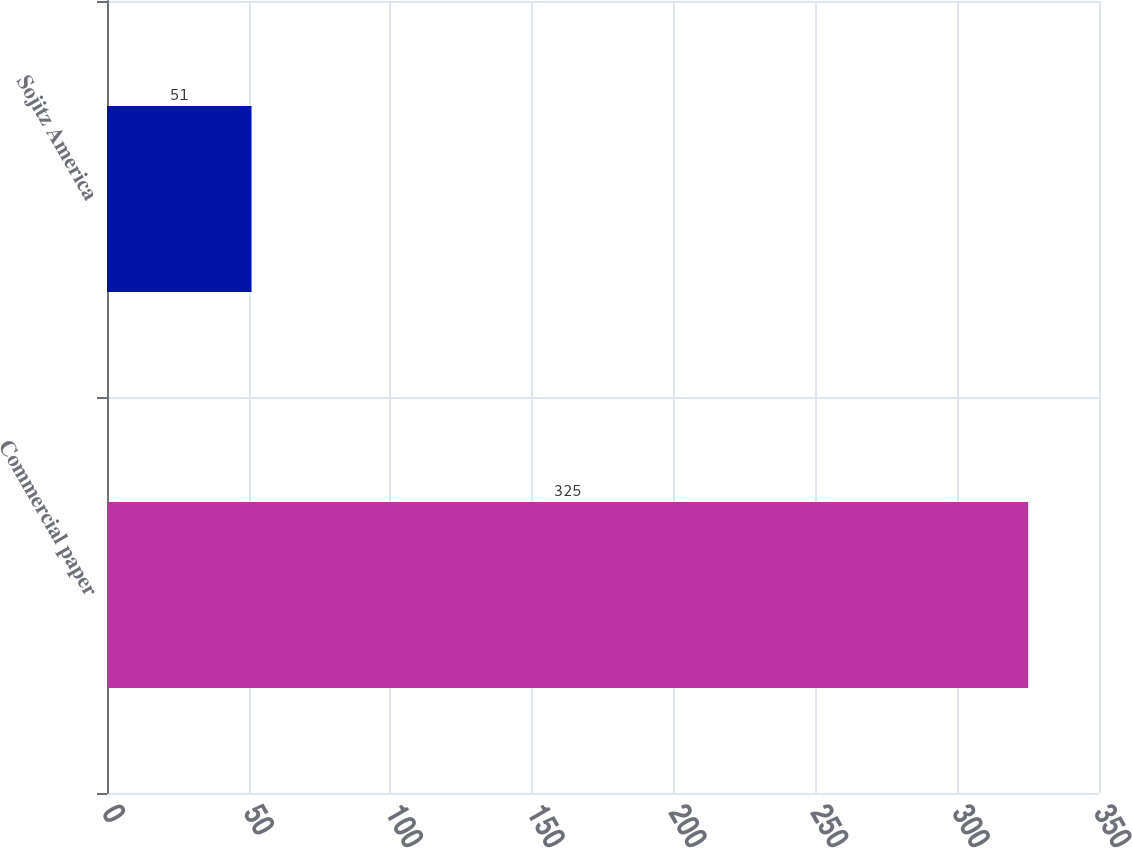Convert chart. <chart><loc_0><loc_0><loc_500><loc_500><bar_chart><fcel>Commercial paper<fcel>Sojitz America<nl><fcel>325<fcel>51<nl></chart> 